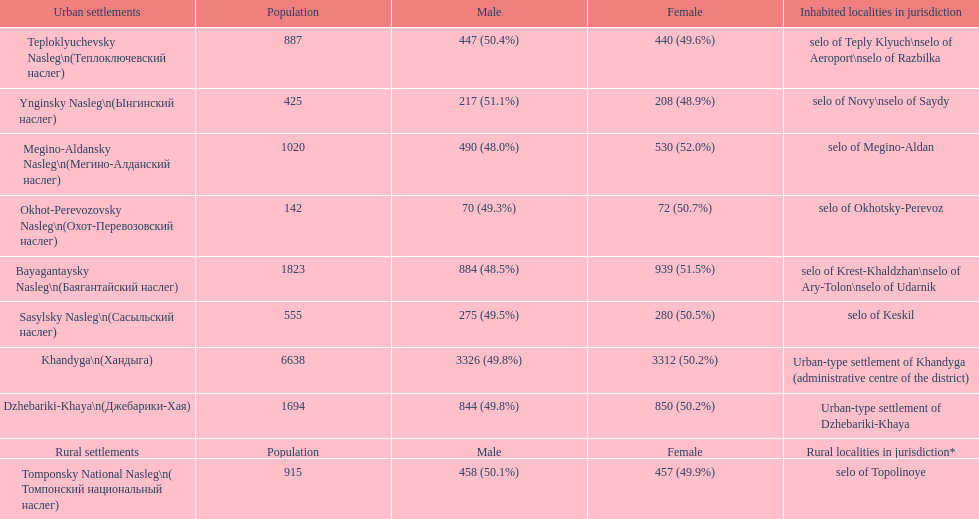Which rural settlement has the most males in their population? Bayagantaysky Nasleg (Áàÿãàíòàéñêèé íàñëåã). 